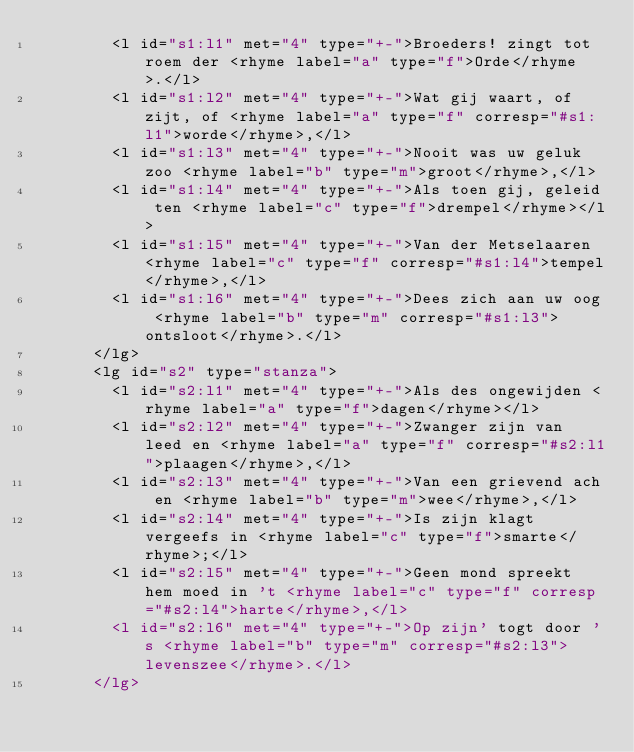<code> <loc_0><loc_0><loc_500><loc_500><_XML_>        <l id="s1:l1" met="4" type="+-">Broeders! zingt tot roem der <rhyme label="a" type="f">Orde</rhyme>.</l>
        <l id="s1:l2" met="4" type="+-">Wat gij waart, of zijt, of <rhyme label="a" type="f" corresp="#s1:l1">worde</rhyme>,</l>
        <l id="s1:l3" met="4" type="+-">Nooit was uw geluk zoo <rhyme label="b" type="m">groot</rhyme>,</l>
        <l id="s1:l4" met="4" type="+-">Als toen gij, geleid ten <rhyme label="c" type="f">drempel</rhyme></l>
        <l id="s1:l5" met="4" type="+-">Van der Metselaaren <rhyme label="c" type="f" corresp="#s1:l4">tempel</rhyme>,</l>
        <l id="s1:l6" met="4" type="+-">Dees zich aan uw oog <rhyme label="b" type="m" corresp="#s1:l3">ontsloot</rhyme>.</l>
      </lg>
      <lg id="s2" type="stanza">
        <l id="s2:l1" met="4" type="+-">Als des ongewijden <rhyme label="a" type="f">dagen</rhyme></l>
        <l id="s2:l2" met="4" type="+-">Zwanger zijn van leed en <rhyme label="a" type="f" corresp="#s2:l1">plaagen</rhyme>,</l>
        <l id="s2:l3" met="4" type="+-">Van een grievend ach en <rhyme label="b" type="m">wee</rhyme>,</l>
        <l id="s2:l4" met="4" type="+-">Is zijn klagt vergeefs in <rhyme label="c" type="f">smarte</rhyme>;</l>
        <l id="s2:l5" met="4" type="+-">Geen mond spreekt hem moed in 't <rhyme label="c" type="f" corresp="#s2:l4">harte</rhyme>,</l>
        <l id="s2:l6" met="4" type="+-">Op zijn' togt door 's <rhyme label="b" type="m" corresp="#s2:l3">levenszee</rhyme>.</l>
      </lg></code> 